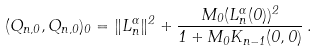Convert formula to latex. <formula><loc_0><loc_0><loc_500><loc_500>( Q _ { n , 0 } , Q _ { n , 0 } ) _ { 0 } = \| L _ { n } ^ { \alpha } \| ^ { 2 } + \frac { M _ { 0 } ( L _ { n } ^ { \alpha } ( 0 ) ) ^ { 2 } } { 1 + M _ { 0 } K _ { n - 1 } ( 0 , 0 ) } \, .</formula> 